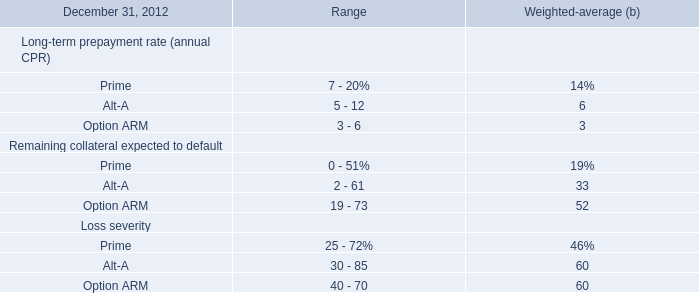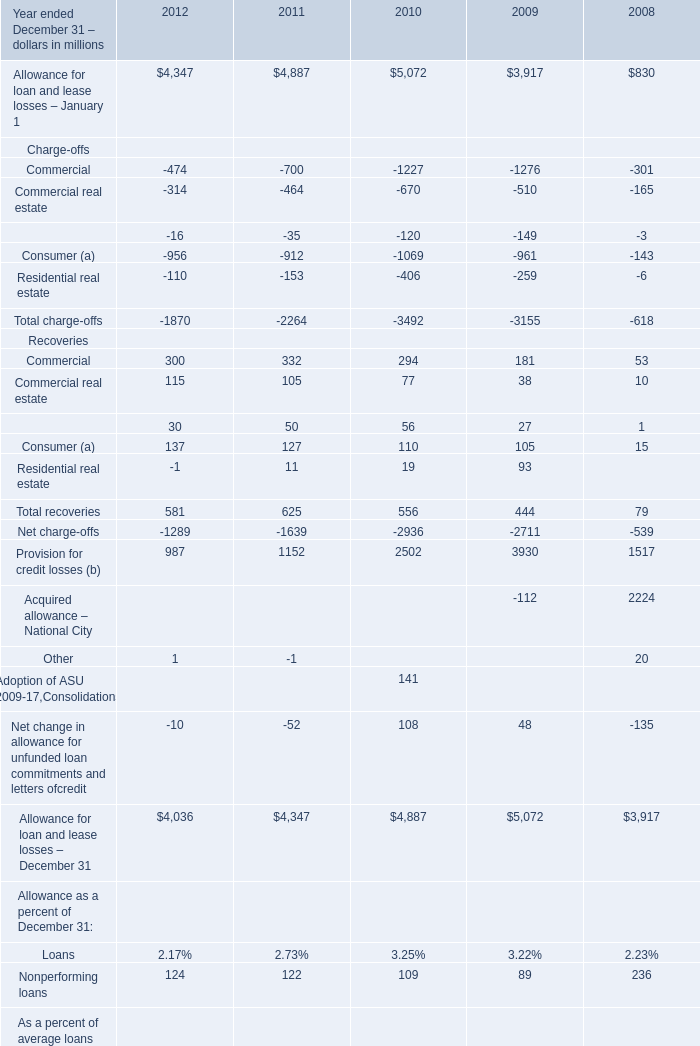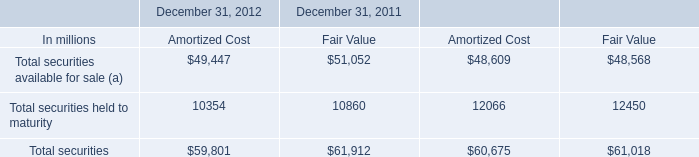In the year with lowest amount of Commercial, what's the increasing rate of Consumer (a)? 
Computations: ((-961 - -143) / -961)
Answer: 0.8512. What was the average value ofCommercialCommercial real estateEquipment lease financingin 2012 (in million) 
Computations: (((-474 - 314) - 16) / 3)
Answer: -268.0. 